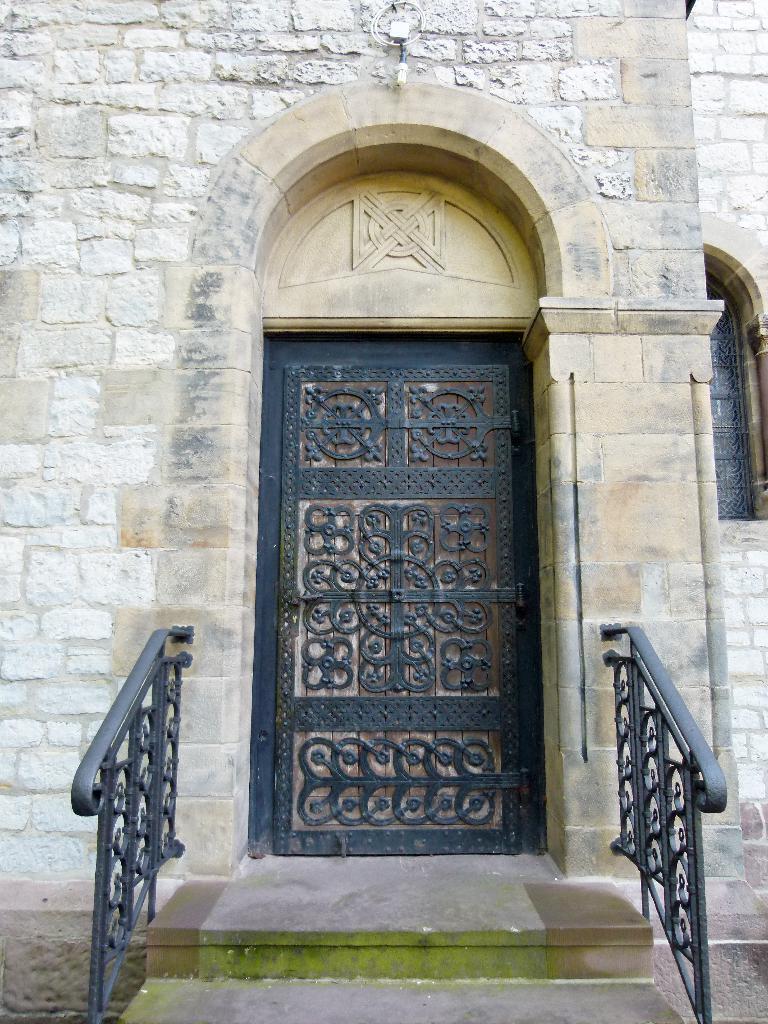Please provide a concise description of this image. In this image in the front there are steps and railings. In the background there is a door and there is a wall and there is a window. 